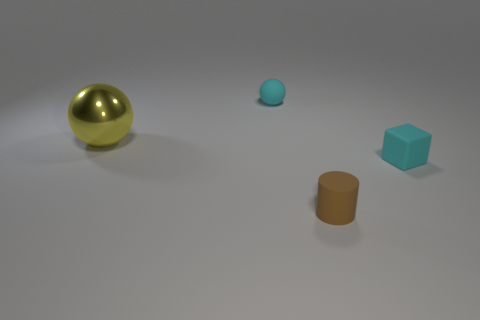Add 3 gray objects. How many objects exist? 7 Subtract all cylinders. How many objects are left? 3 Add 4 small brown rubber things. How many small brown rubber things exist? 5 Subtract 0 purple cylinders. How many objects are left? 4 Subtract all large yellow things. Subtract all big yellow metal blocks. How many objects are left? 3 Add 4 small cylinders. How many small cylinders are left? 5 